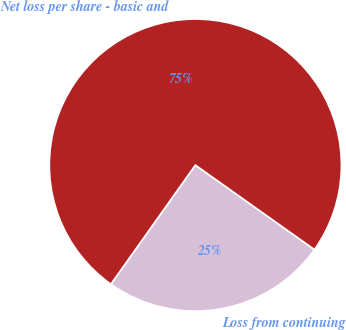Convert chart to OTSL. <chart><loc_0><loc_0><loc_500><loc_500><pie_chart><fcel>Loss from continuing<fcel>Net loss per share - basic and<nl><fcel>25.0%<fcel>75.0%<nl></chart> 